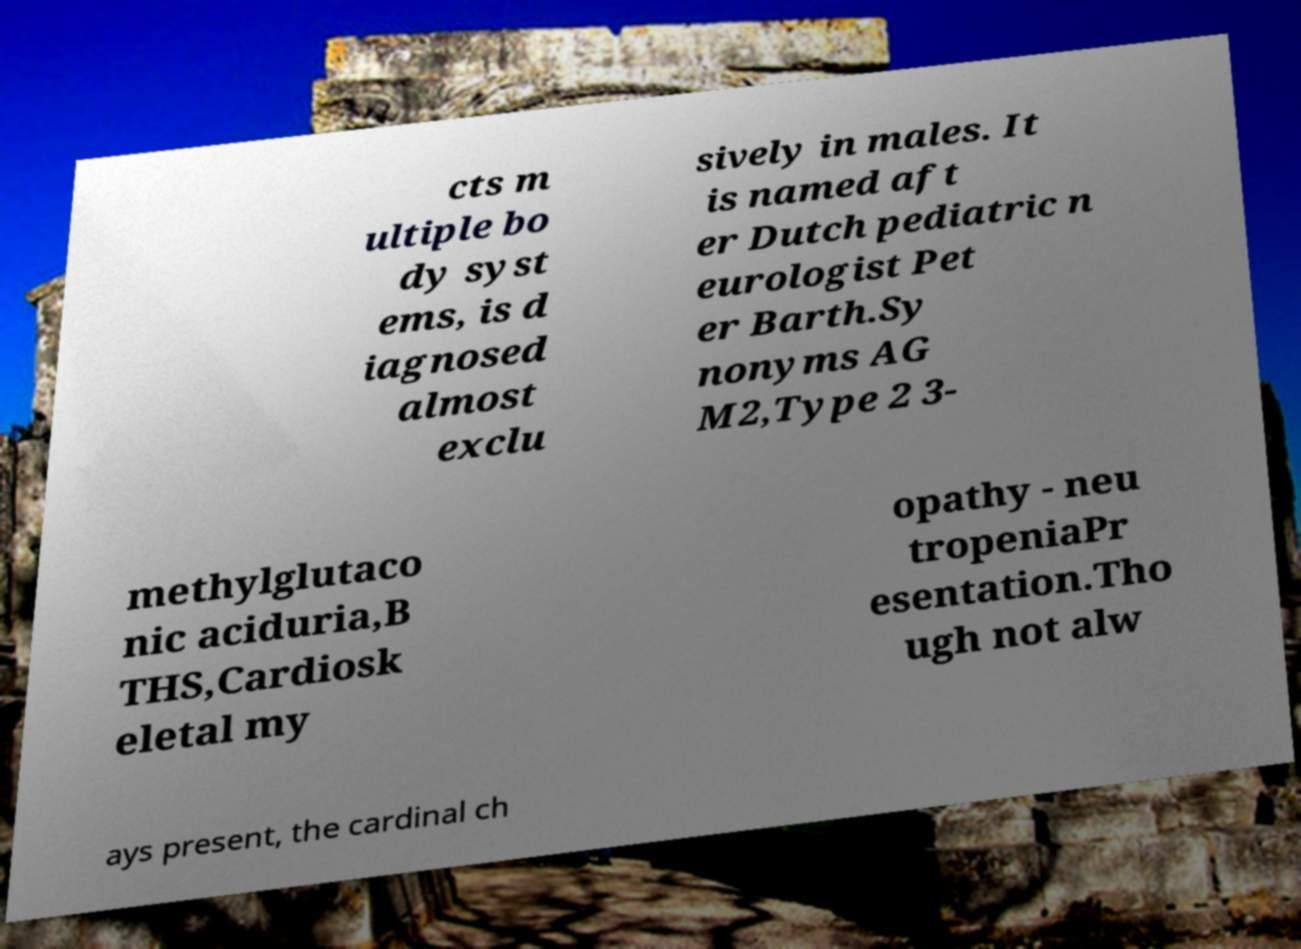For documentation purposes, I need the text within this image transcribed. Could you provide that? cts m ultiple bo dy syst ems, is d iagnosed almost exclu sively in males. It is named aft er Dutch pediatric n eurologist Pet er Barth.Sy nonyms AG M2,Type 2 3- methylglutaco nic aciduria,B THS,Cardiosk eletal my opathy - neu tropeniaPr esentation.Tho ugh not alw ays present, the cardinal ch 